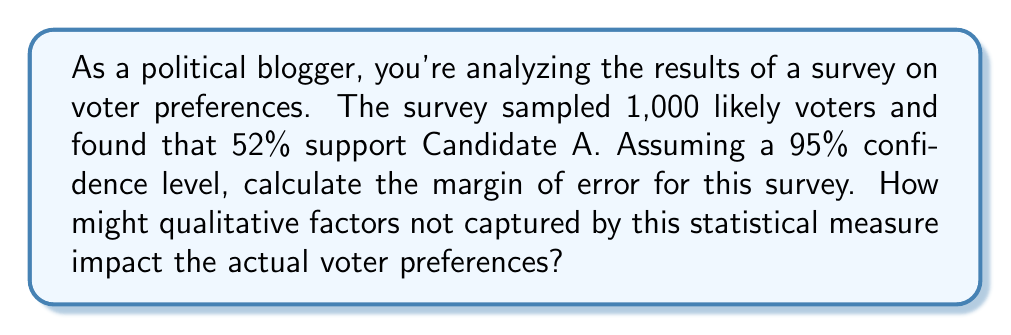Provide a solution to this math problem. To calculate the margin of error for this survey, we'll use the formula:

$$ \text{Margin of Error} = z \sqrt{\frac{p(1-p)}{n}} $$

Where:
- $z$ is the z-score for the desired confidence level (1.96 for 95% confidence)
- $p$ is the sample proportion (0.52 in this case)
- $n$ is the sample size (1,000)

Step 1: Identify the values
$z = 1.96$
$p = 0.52$
$n = 1000$

Step 2: Plug the values into the formula
$$ \text{Margin of Error} = 1.96 \sqrt{\frac{0.52(1-0.52)}{1000}} $$

Step 3: Simplify inside the square root
$$ \text{Margin of Error} = 1.96 \sqrt{\frac{0.52(0.48)}{1000}} = 1.96 \sqrt{\frac{0.2496}{1000}} $$

Step 4: Calculate
$$ \text{Margin of Error} = 1.96 \sqrt{0.0002496} \approx 0.0309 $$

Step 5: Convert to percentage
$$ \text{Margin of Error} \approx 3.09\% $$

Regarding qualitative factors, it's important to note that this statistical measure doesn't account for:
1. Voter enthusiasm and turnout
2. Last-minute events or scandals
3. Effectiveness of get-out-the-vote efforts
4. Undecided voters' final decisions
5. Sampling biases in the survey methodology

These factors could significantly impact actual voter preferences beyond what the quantitative margin of error suggests.
Answer: The margin of error is approximately 3.09%. However, qualitative factors not captured by this statistical measure could potentially have a more significant impact on actual voter preferences than the calculated margin of error suggests. 